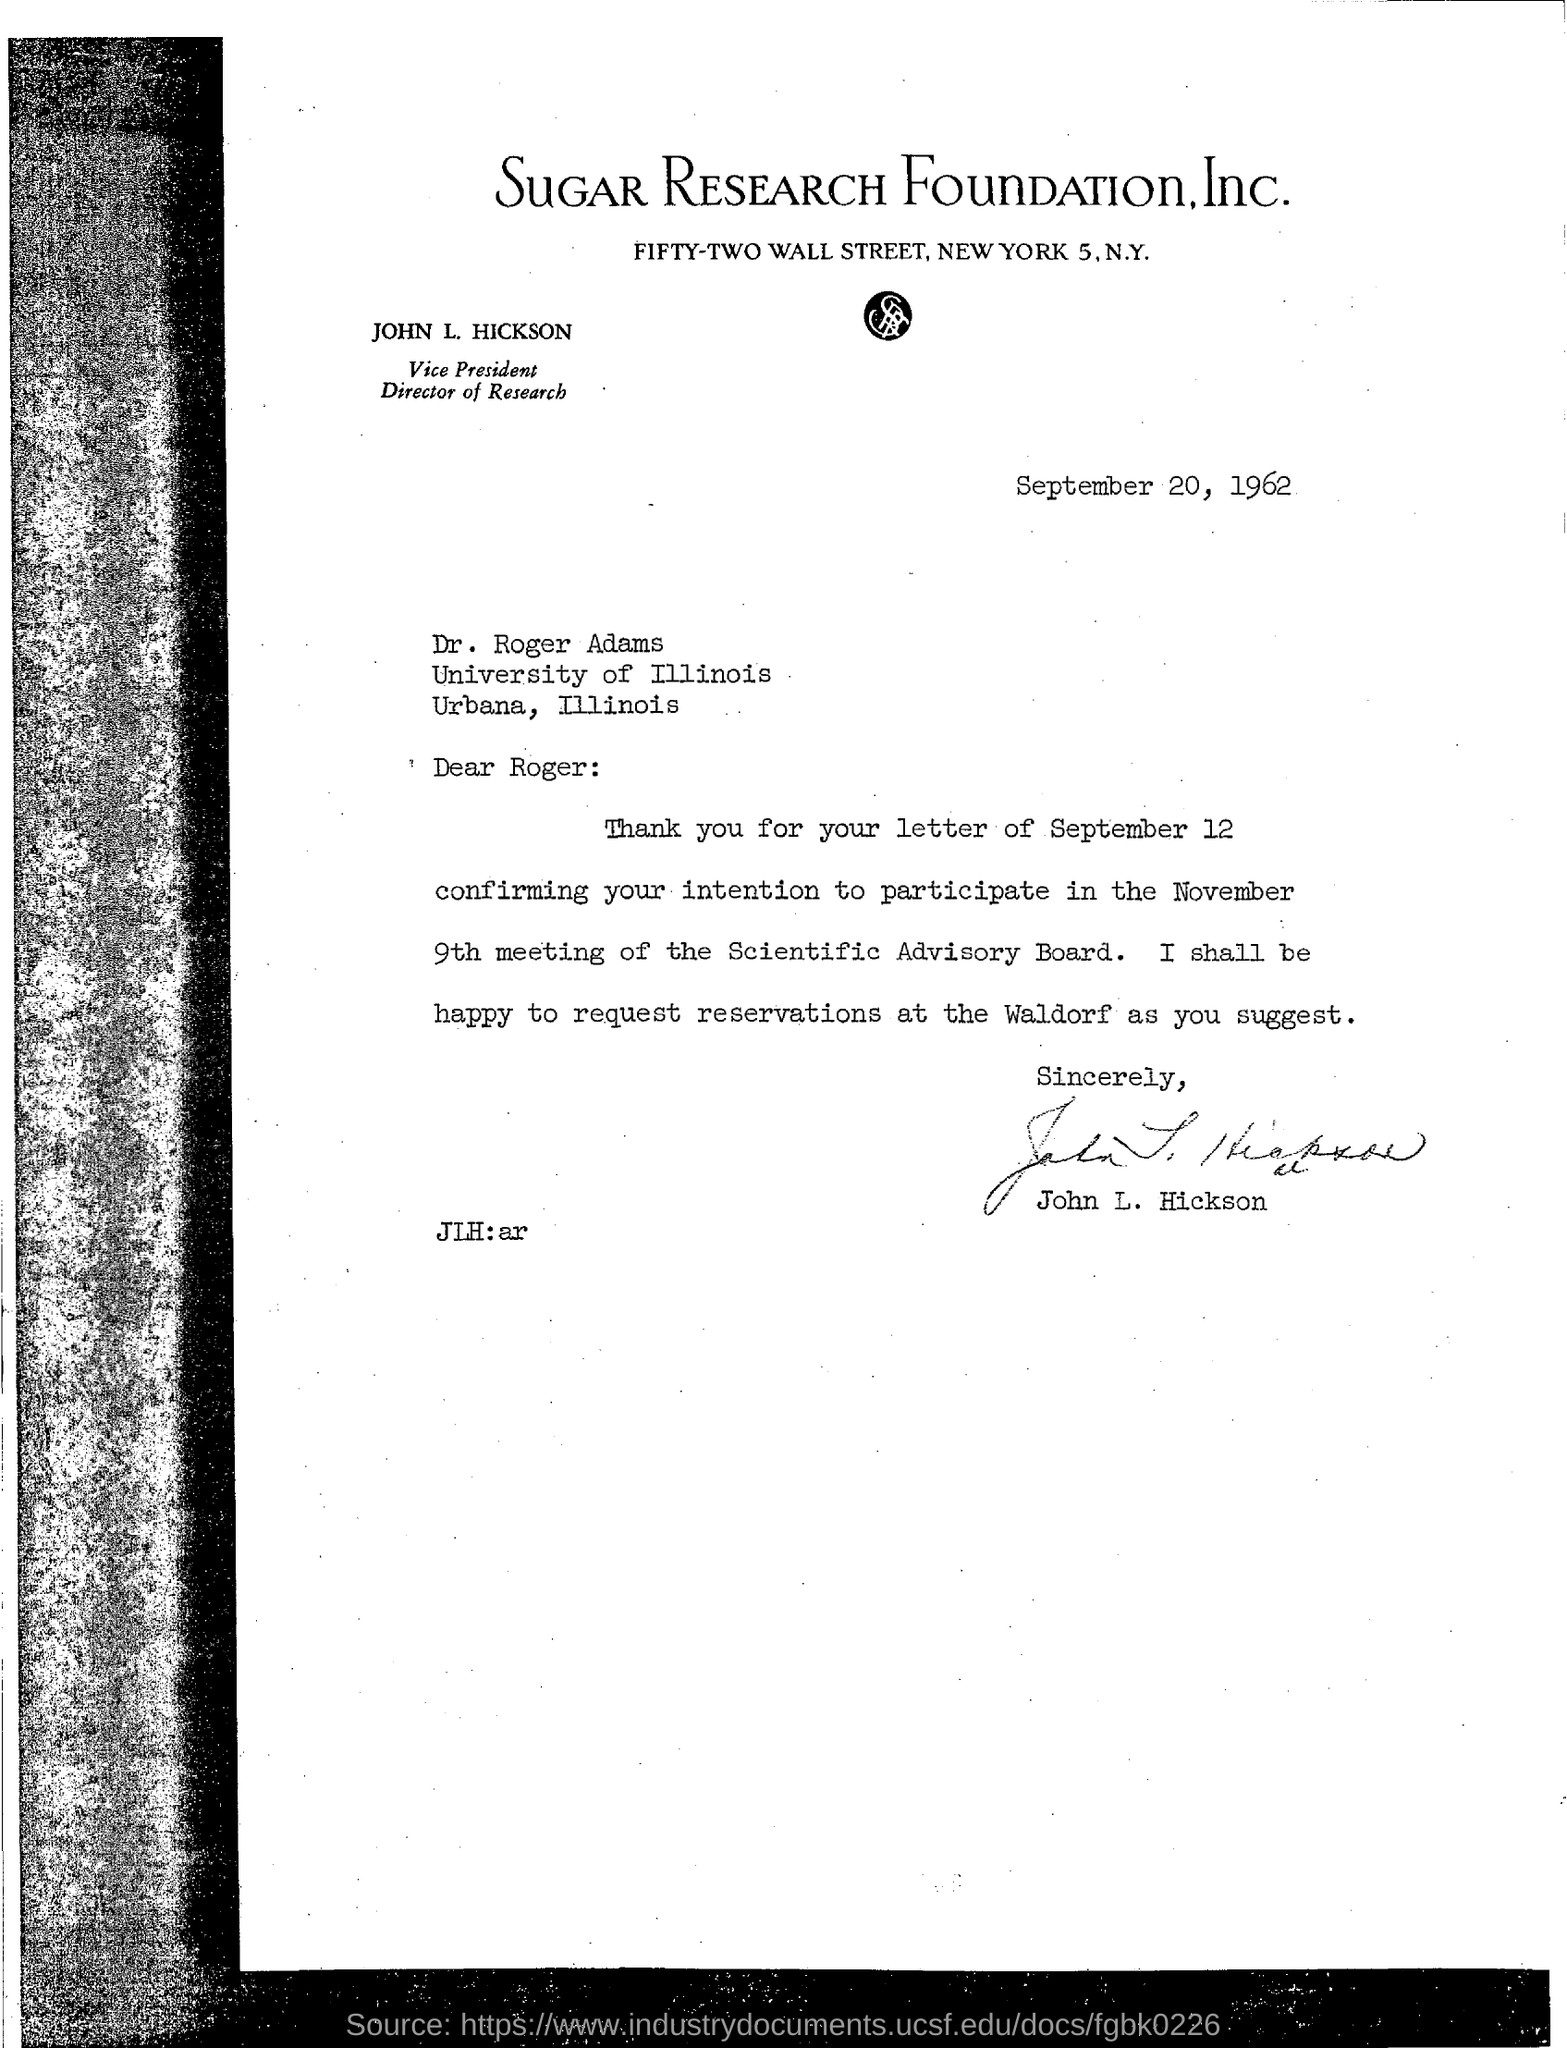Give some essential details in this illustration. The meeting is scheduled to be held on November 9th. The Vice President and Director of Research is John L. Hickson. The document is dated September 20, 1962. 